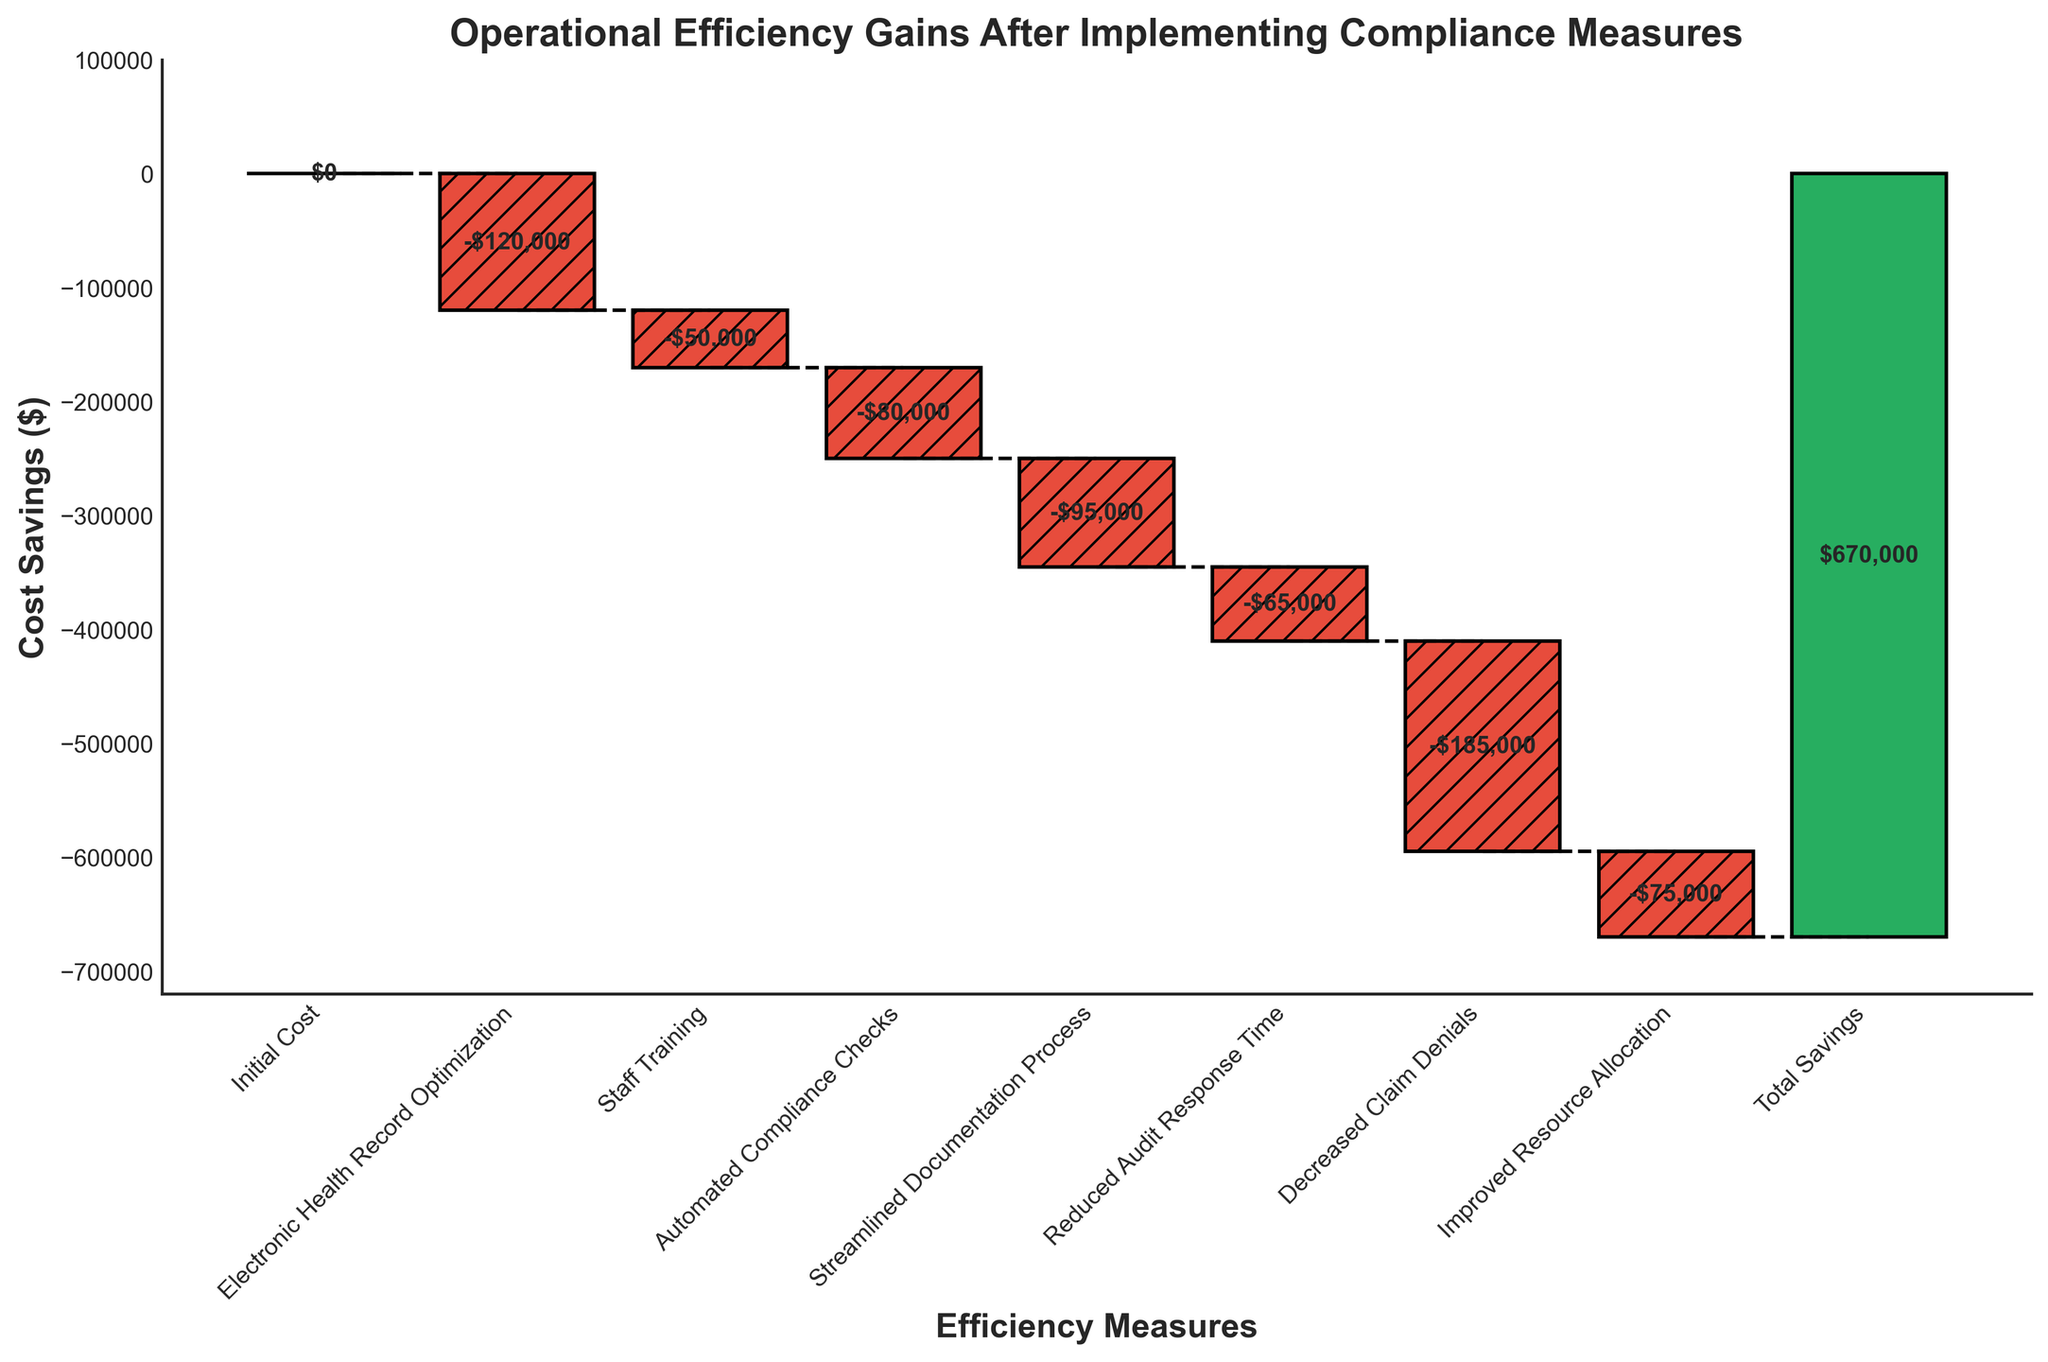What's the title of the figure? The title is displayed at the top of the figure and describes the overall context of the chart.
Answer: Operational Efficiency Gains After Implementing Compliance Measures How many efficiency measures are listed in the chart? There are 7 efficiency measures listed, excluding the "Initial Cost" and "Total Savings". These measures are shown as different bars in the chart.
Answer: 7 What are the values associated with the "Electronic Health Record Optimization" and "Staff Training"? The values are labeled next to their respective bars in the chart. "Electronic Health Record Optimization" is -$120,000 and "Staff Training" is -$50,000.
Answer: -$120,000 and -$50,000 What is the total cost reduction achieved from "Reduced Audit Response Time" and "Improved Resource Allocation"? Add the values of the two measures: -$65,000 + -$75,000 = -$140,000.
Answer: -$140,000 Which efficiency measure led to the highest cost savings? Observe the values associated with each efficiency measure. "Decreased Claim Denials" has the highest value, which is -$185,000.
Answer: Decreased Claim Denials How does the total savings compare to the initial cost? The chart shows "Initial Cost" at $0 and "Total Savings" at $670,000, indicating the total savings are $670,000, significantly higher than the initial cost.
Answer: $670,000 more What is the cumulative cost saving before the "Total Savings" bar? Sum the individual savings from all measures before "Total Savings" (from the chart): -120,000 + -50,000 + -80,000 + -95,000 + -65,000 + -185,000 + -75,000 = -670,000.
Answer: -$670,000 How much did the "Streamlined Documentation Process" save compared to "Automated Compliance Checks"? Compare the values: -$95,000 ("Streamlined Documentation Process") vs. -$80,000 ("Automated Compliance Checks").
Answer: $15,000 more What's the combined saving from measures aimed at documentation and audit efficiency (i.e., "Streamlined Documentation Process" and "Reduced Audit Response Time")? Add the values for these measures: -$95,000 + -$65,000 = -$160,000.
Answer: -$160,000 